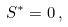<formula> <loc_0><loc_0><loc_500><loc_500>S ^ { * } = 0 \, ,</formula> 